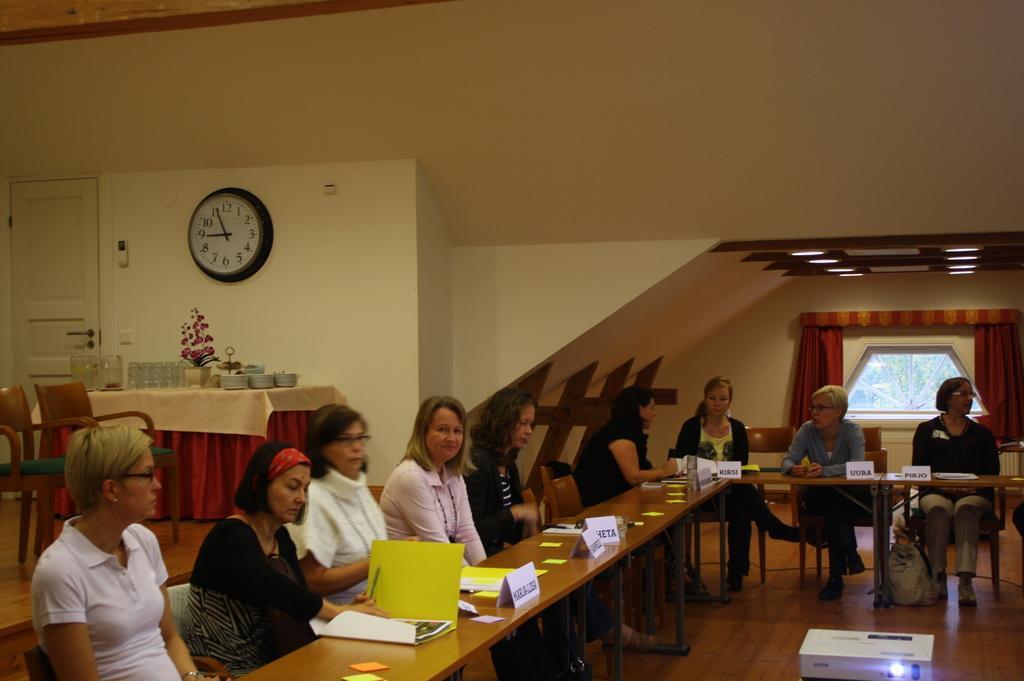Please provide a concise description of this image. This is an inside view. Here I can see few people are sitting on the chairs in front of the table. On the table there are some files, name boards and papers. On the right bottom of the image I can see a projector. On the left side there is a table which is covered with a cloth and on that I can see few glasses, bowls and a flower plant. Beside the table there are two chairs and also there is a door. On the top of the table I can see a clock is attached to the wall. In the background there is a window and on both sides I can see the curtains. On the top there are some lights. 